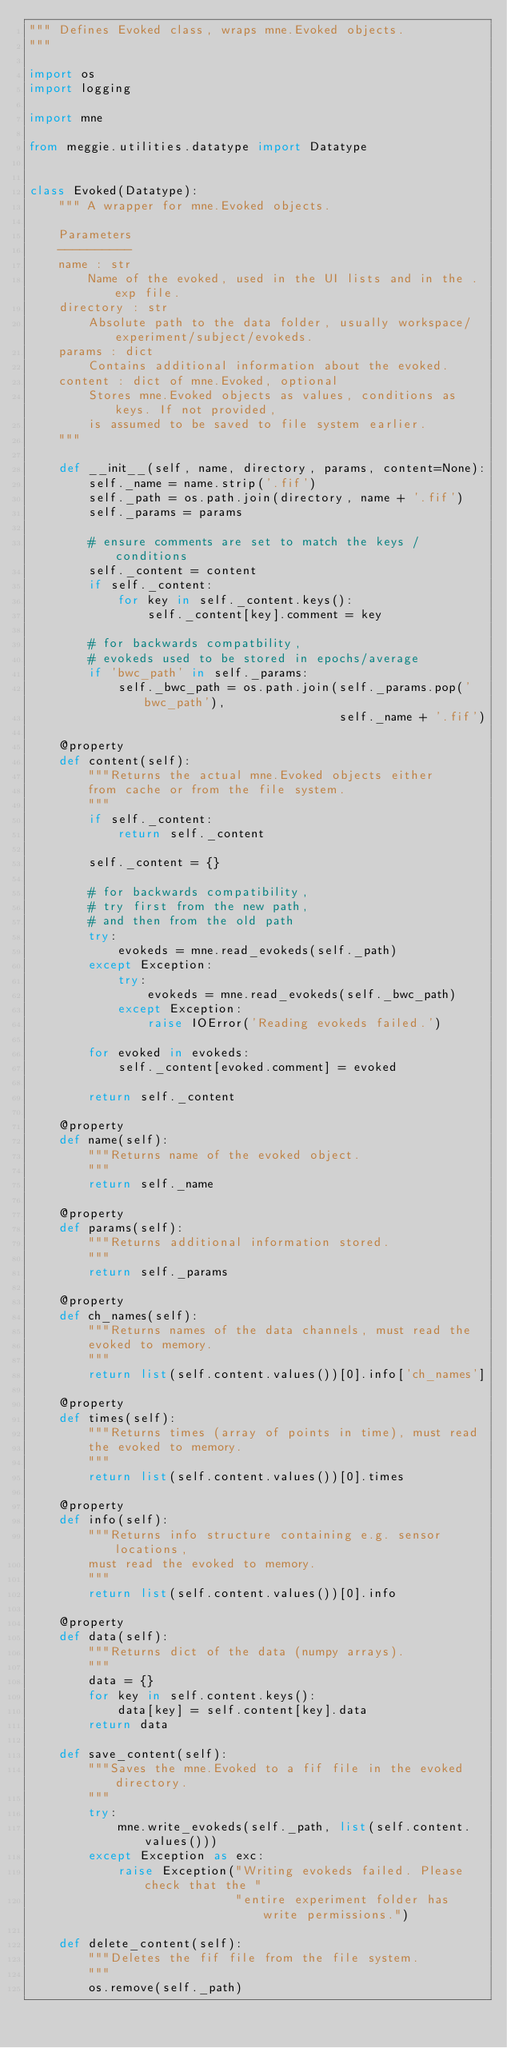Convert code to text. <code><loc_0><loc_0><loc_500><loc_500><_Python_>""" Defines Evoked class, wraps mne.Evoked objects.
"""

import os
import logging

import mne

from meggie.utilities.datatype import Datatype


class Evoked(Datatype):
    """ A wrapper for mne.Evoked objects.

    Parameters
    ----------
    name : str
        Name of the evoked, used in the UI lists and in the .exp file.
    directory : str
        Absolute path to the data folder, usually workspace/experiment/subject/evokeds.
    params : dict
        Contains additional information about the evoked.
    content : dict of mne.Evoked, optional
        Stores mne.Evoked objects as values, conditions as keys. If not provided,
        is assumed to be saved to file system earlier.
    """

    def __init__(self, name, directory, params, content=None):
        self._name = name.strip('.fif')
        self._path = os.path.join(directory, name + '.fif')
        self._params = params

        # ensure comments are set to match the keys / conditions
        self._content = content
        if self._content:
            for key in self._content.keys():
                self._content[key].comment = key

        # for backwards compatbility,
        # evokeds used to be stored in epochs/average
        if 'bwc_path' in self._params:
            self._bwc_path = os.path.join(self._params.pop('bwc_path'),
                                          self._name + '.fif')

    @property
    def content(self):
        """Returns the actual mne.Evoked objects either
        from cache or from the file system.
        """
        if self._content:
            return self._content

        self._content = {}

        # for backwards compatibility,
        # try first from the new path,
        # and then from the old path
        try:
            evokeds = mne.read_evokeds(self._path)
        except Exception:
            try:
                evokeds = mne.read_evokeds(self._bwc_path)
            except Exception:
                raise IOError('Reading evokeds failed.')

        for evoked in evokeds:
            self._content[evoked.comment] = evoked

        return self._content

    @property
    def name(self):
        """Returns name of the evoked object.
        """
        return self._name

    @property
    def params(self):
        """Returns additional information stored.
        """
        return self._params

    @property
    def ch_names(self):
        """Returns names of the data channels, must read the
        evoked to memory.
        """
        return list(self.content.values())[0].info['ch_names']

    @property
    def times(self):
        """Returns times (array of points in time), must read
        the evoked to memory.
        """
        return list(self.content.values())[0].times

    @property
    def info(self):
        """Returns info structure containing e.g. sensor locations,
        must read the evoked to memory.
        """
        return list(self.content.values())[0].info

    @property
    def data(self):
        """Returns dict of the data (numpy arrays).
        """
        data = {}
        for key in self.content.keys():
            data[key] = self.content[key].data
        return data

    def save_content(self):
        """Saves the mne.Evoked to a fif file in the evoked directory.
        """
        try:
            mne.write_evokeds(self._path, list(self.content.values()))
        except Exception as exc:
            raise Exception("Writing evokeds failed. Please check that the "
                            "entire experiment folder has write permissions.")

    def delete_content(self):
        """Deletes the fif file from the file system.
        """
        os.remove(self._path)
</code> 